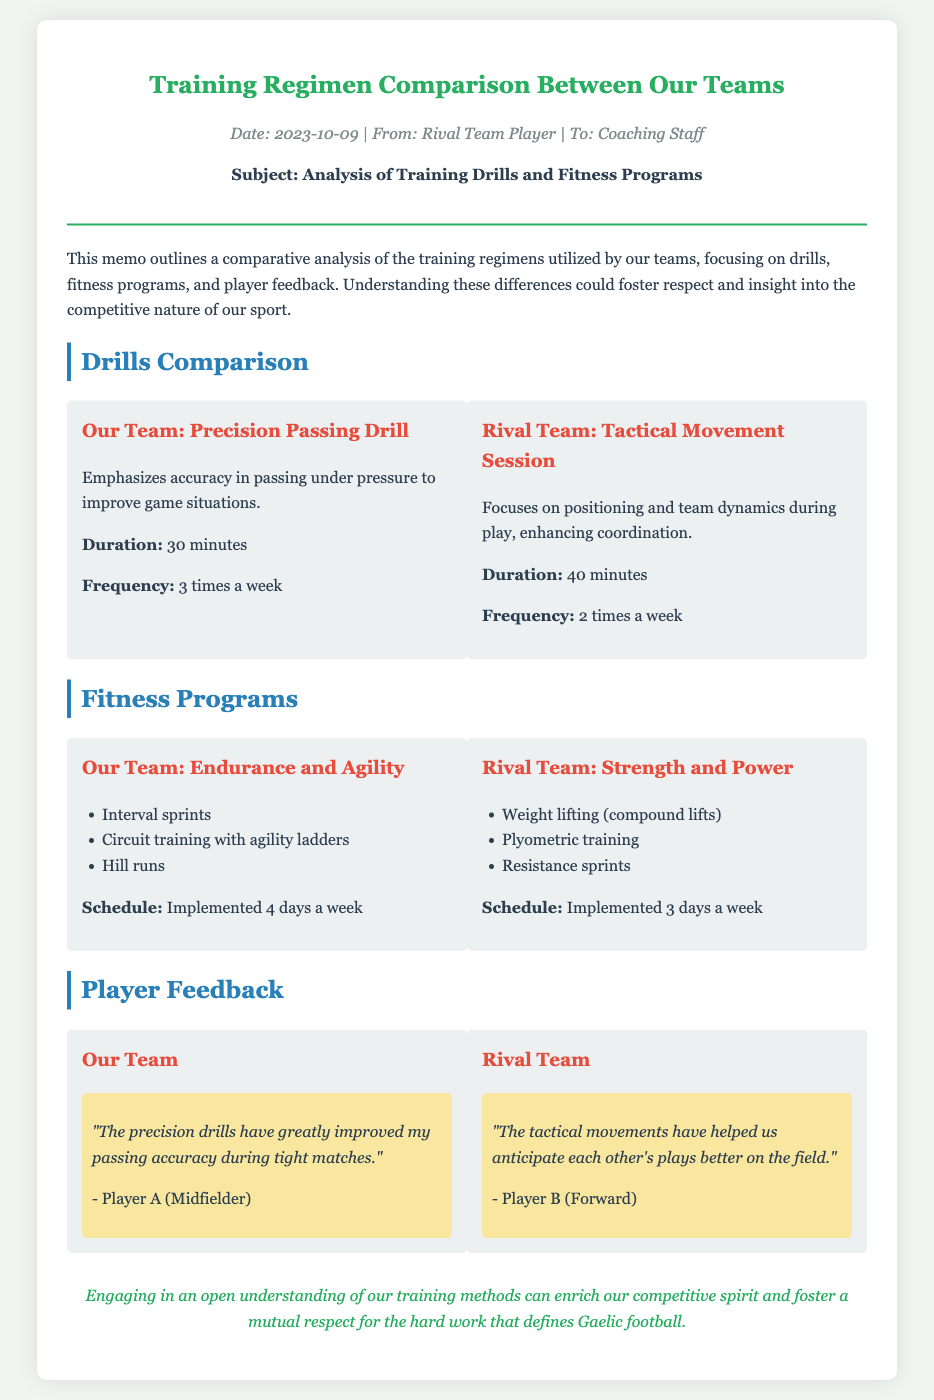What is the subject of the memo? The subject is explicitly stated in the memo as "Analysis of Training Drills and Fitness Programs."
Answer: Analysis of Training Drills and Fitness Programs How long is the Tactical Movement Session? The duration is mentioned in the section comparing drills, specifically for the rival team's activity.
Answer: 40 minutes How many times a week does Our Team implement the Endurance and Agility fitness program? The schedule is provided in the fitness programs comparison section, indicating the frequency of this training.
Answer: 4 days a week Who provided feedback for the Rival Team? The memo lists Player B as a representative of the rival team's feedback in the player feedback section.
Answer: Player B What type of drills does Our Team focus on? The drills section describes the specific drill used by Our Team to improve playing conditions, prominently mentioned there.
Answer: Precision Passing Drill Which fitness training method involves compound lifts? The fitness comparison section identifies this training method as key in the rival team's schedule and drills.
Answer: Strength and Power How often does the Rival Team conduct their fitness program? The schedule is included in the fitness programs comparison section, detailing the frequency of the rival team's workouts.
Answer: 3 days a week What is the conclusion of the memo? The last paragraph summarizes the document's overall message, highlighting the importance of understanding training methods.
Answer: Engaging in an open understanding of our training methods can enrich our competitive spirit and foster a mutual respect for the hard work that defines Gaelic football 